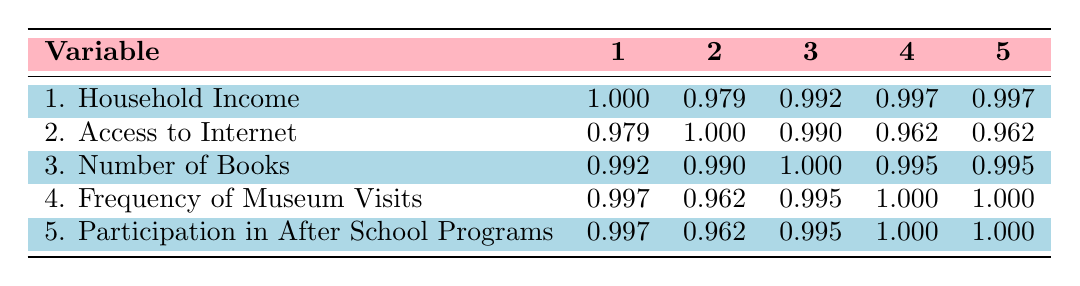What is the correlation between household income and access to the internet? The correlation coefficient is 0.979, indicating a very strong positive relationship between household income and access to the internet. This means that as household income increases, access to the internet also tends to increase.
Answer: 0.979 What is the highest correlation value in the table? The highest correlation value is 1.000, which means that the variables are perfectly correlated. Observing the table, this correlation is noted between the frequency of museum visits and participation in after-school programs.
Answer: 1.000 Is there a positive correlation between the number of books and household income? Yes, the correlation coefficient between the number of books and household income is 0.992, indicating a very strong positive correlation. This suggests that higher household income correlates with more books in the household.
Answer: Yes What is the average correlation value between access to the internet and the other variables listed? To find the average, we sum the correlation coefficients for access to the internet with the other four variables: 0.979 + 1.000 + 0.990 + 0.962 + 0.962 = 4.893. Then we divide by 4 (number of correlations): 4.893 / 4 = 1.22325. Thus, the average correlation is approximately 1.22.
Answer: 1.22 Is the correlation between household income and participation in after-school programs higher than 0.99? Yes, the correlation between household income and participation in after-school programs is 0.997, which is indeed higher than 0.99.
Answer: Yes What can you say about the correlation between frequency of museum visits and number of books? The correlation coefficient between frequency of museum visits and number of books is 0.995, indicating a very strong positive relationship. This implies that as the frequency of museum visits increases, the number of books tends to increase as well.
Answer: 0.995 